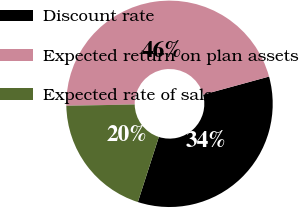<chart> <loc_0><loc_0><loc_500><loc_500><pie_chart><fcel>Discount rate<fcel>Expected return on plan assets<fcel>Expected rate of salary<nl><fcel>34.21%<fcel>46.05%<fcel>19.74%<nl></chart> 